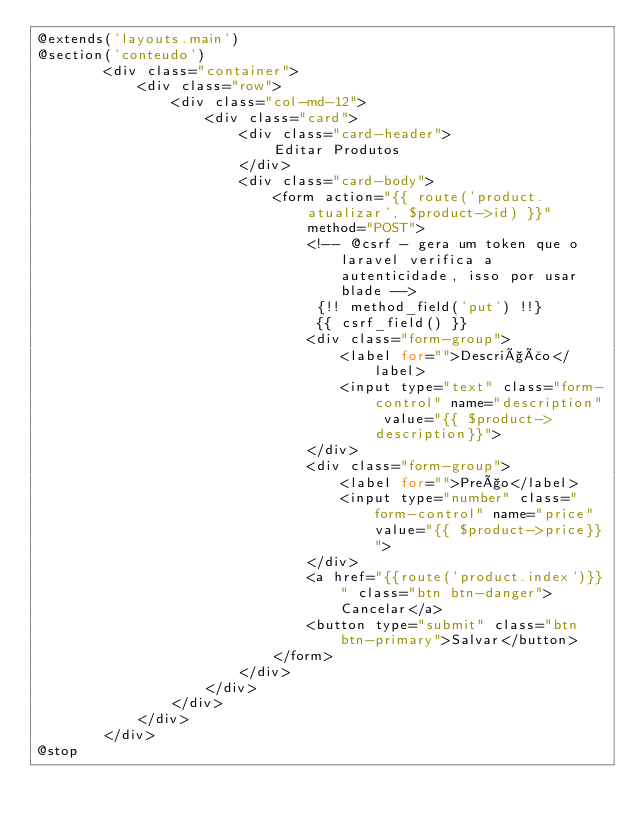<code> <loc_0><loc_0><loc_500><loc_500><_PHP_>@extends('layouts.main')
@section('conteudo')
        <div class="container">
            <div class="row">
                <div class="col-md-12">
                    <div class="card">
                        <div class="card-header">
                            Editar Produtos                            
                        </div>
                        <div class="card-body">
                            <form action="{{ route('product.atualizar', $product->id) }}" method="POST">
                                <!-- @csrf - gera um token que o laravel verifica a autenticidade, isso por usar blade -->
                                 {!! method_field('put') !!}                                
                                 {{ csrf_field() }}
                                <div class="form-group">
                                    <label for="">Descrição</label>
                                    <input type="text" class="form-control" name="description" value="{{ $product->description}}">
                                </div>
                                <div class="form-group">
                                    <label for="">Preço</label>
                                    <input type="number" class="form-control" name="price" value="{{ $product->price}}">
                                </div>
                                <a href="{{route('product.index')}}" class="btn btn-danger">Cancelar</a>
                                <button type="submit" class="btn btn-primary">Salvar</button>
                            </form>
                        </div>
                    </div>
                </div>
            </div>
        </div>
@stop
</code> 